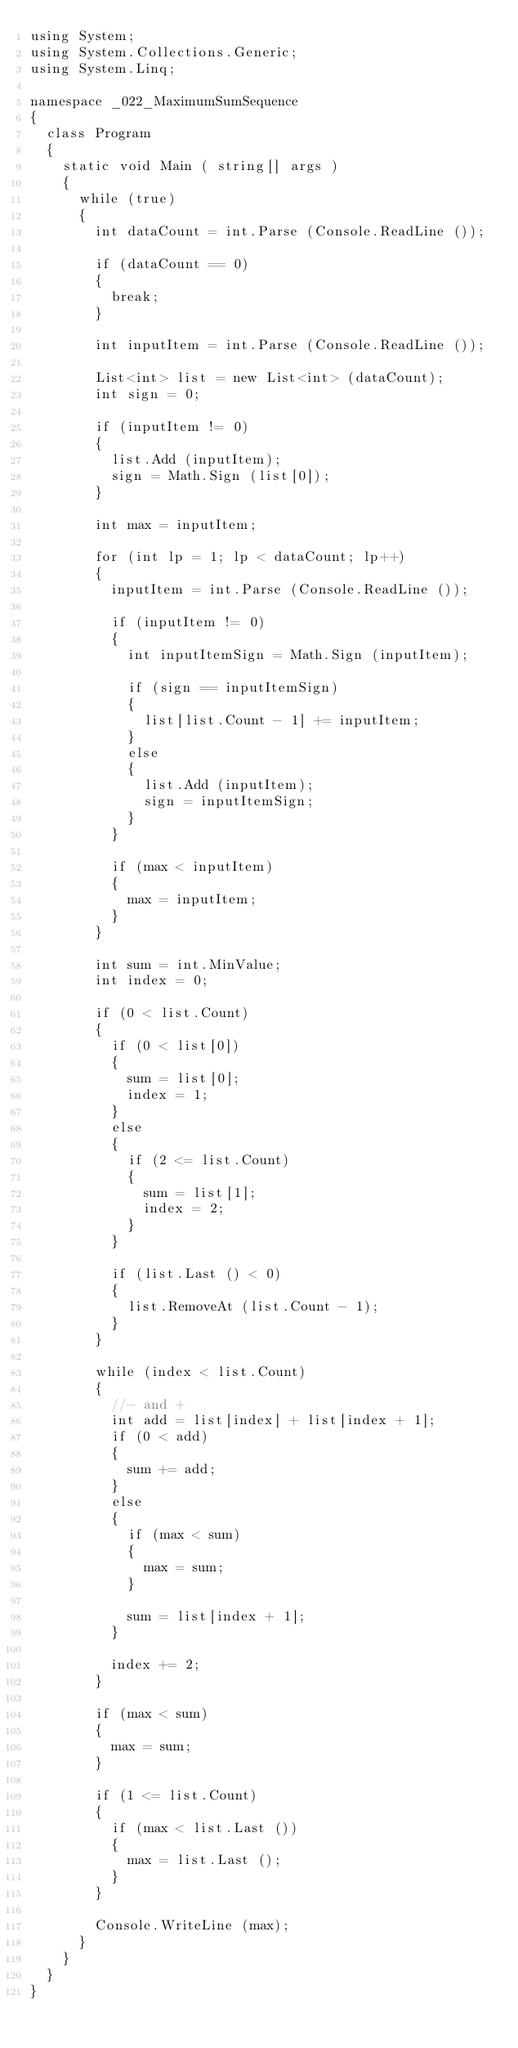Convert code to text. <code><loc_0><loc_0><loc_500><loc_500><_C#_>using System;
using System.Collections.Generic;
using System.Linq;

namespace _022_MaximumSumSequence
{
	class Program
	{
		static void Main ( string[] args )
		{
			while (true)
			{
				int dataCount = int.Parse (Console.ReadLine ());

				if (dataCount == 0)
				{
					break;
				}

				int inputItem = int.Parse (Console.ReadLine ());

				List<int> list = new List<int> (dataCount);
				int sign = 0;

				if (inputItem != 0)
				{
					list.Add (inputItem);
					sign = Math.Sign (list[0]);
				}

				int max = inputItem;

				for (int lp = 1; lp < dataCount; lp++)
				{
					inputItem = int.Parse (Console.ReadLine ());

					if (inputItem != 0)
					{
						int inputItemSign = Math.Sign (inputItem);

						if (sign == inputItemSign)
						{
							list[list.Count - 1] += inputItem;
						}
						else
						{
							list.Add (inputItem);
							sign = inputItemSign;
						}
					}

					if (max < inputItem)
					{
						max = inputItem;
					}
				}

				int sum = int.MinValue;
				int index = 0;

				if (0 < list.Count)
				{
					if (0 < list[0])
					{
						sum = list[0];
						index = 1;
					}
					else
					{
						if (2 <= list.Count)
						{
							sum = list[1];
							index = 2;
						}
					}

					if (list.Last () < 0)
					{
						list.RemoveAt (list.Count - 1);
					}
				}

				while (index < list.Count)
				{
					//- and +
					int add = list[index] + list[index + 1];
					if (0 < add)
					{
						sum += add;
					}
					else
					{
						if (max < sum)
						{
							max = sum;
						}

						sum = list[index + 1];
					}

					index += 2;
				}

				if (max < sum)
				{
					max = sum;
				}

				if (1 <= list.Count)
				{
					if (max < list.Last ())
					{
						max = list.Last ();
					}
				}

				Console.WriteLine (max);
			}
		}
	}
}</code> 